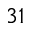<formula> <loc_0><loc_0><loc_500><loc_500>^ { 3 1 }</formula> 